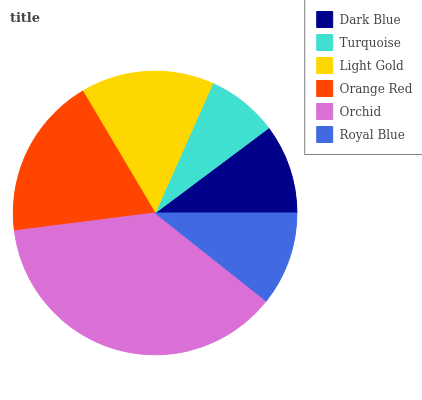Is Turquoise the minimum?
Answer yes or no. Yes. Is Orchid the maximum?
Answer yes or no. Yes. Is Light Gold the minimum?
Answer yes or no. No. Is Light Gold the maximum?
Answer yes or no. No. Is Light Gold greater than Turquoise?
Answer yes or no. Yes. Is Turquoise less than Light Gold?
Answer yes or no. Yes. Is Turquoise greater than Light Gold?
Answer yes or no. No. Is Light Gold less than Turquoise?
Answer yes or no. No. Is Light Gold the high median?
Answer yes or no. Yes. Is Royal Blue the low median?
Answer yes or no. Yes. Is Orchid the high median?
Answer yes or no. No. Is Turquoise the low median?
Answer yes or no. No. 